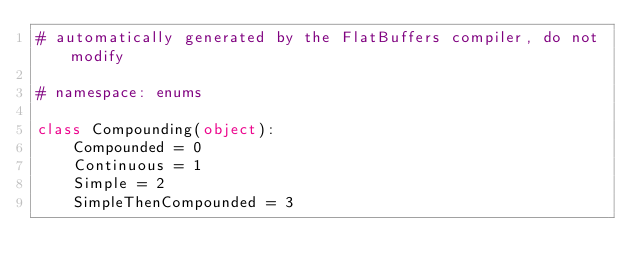<code> <loc_0><loc_0><loc_500><loc_500><_Python_># automatically generated by the FlatBuffers compiler, do not modify

# namespace: enums

class Compounding(object):
    Compounded = 0
    Continuous = 1
    Simple = 2
    SimpleThenCompounded = 3

</code> 